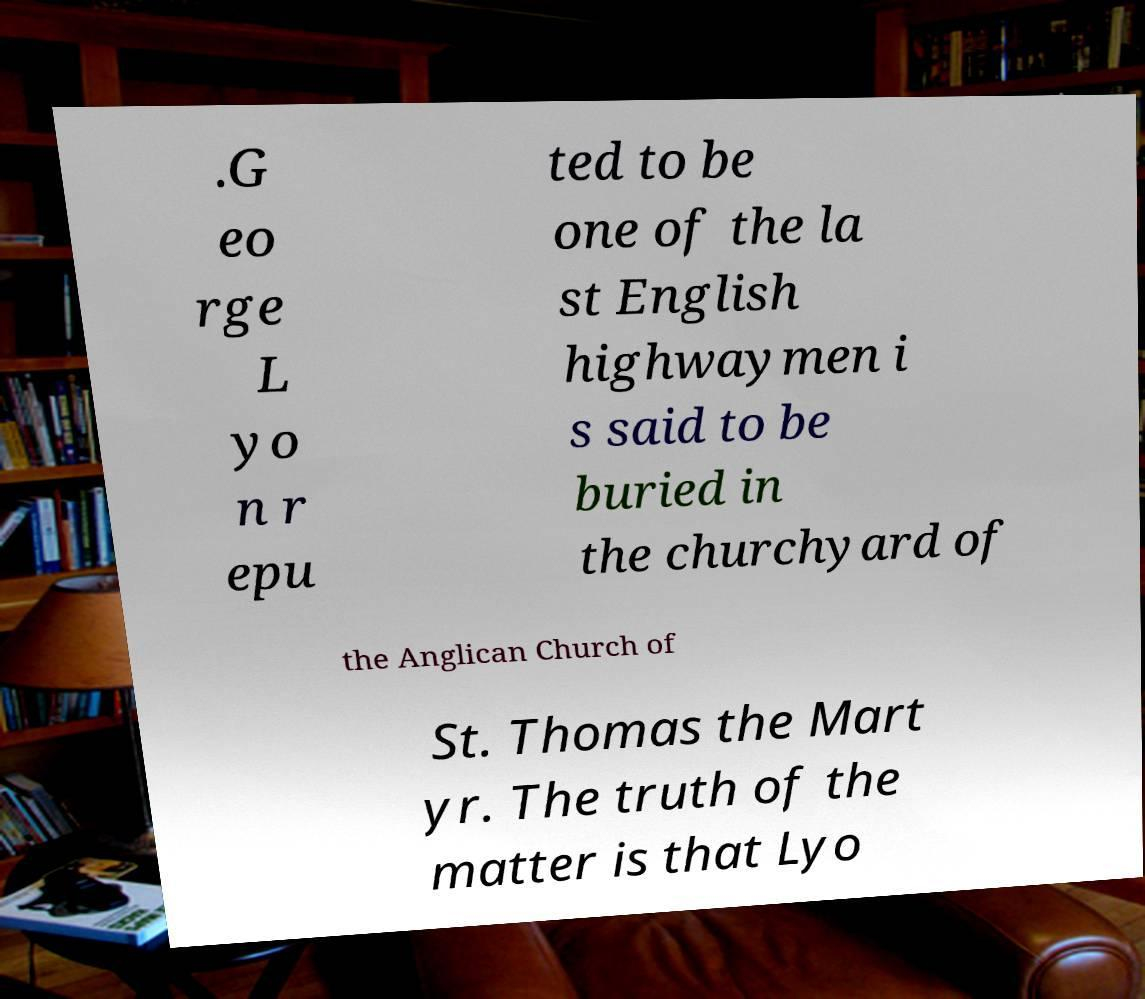Please read and relay the text visible in this image. What does it say? .G eo rge L yo n r epu ted to be one of the la st English highwaymen i s said to be buried in the churchyard of the Anglican Church of St. Thomas the Mart yr. The truth of the matter is that Lyo 